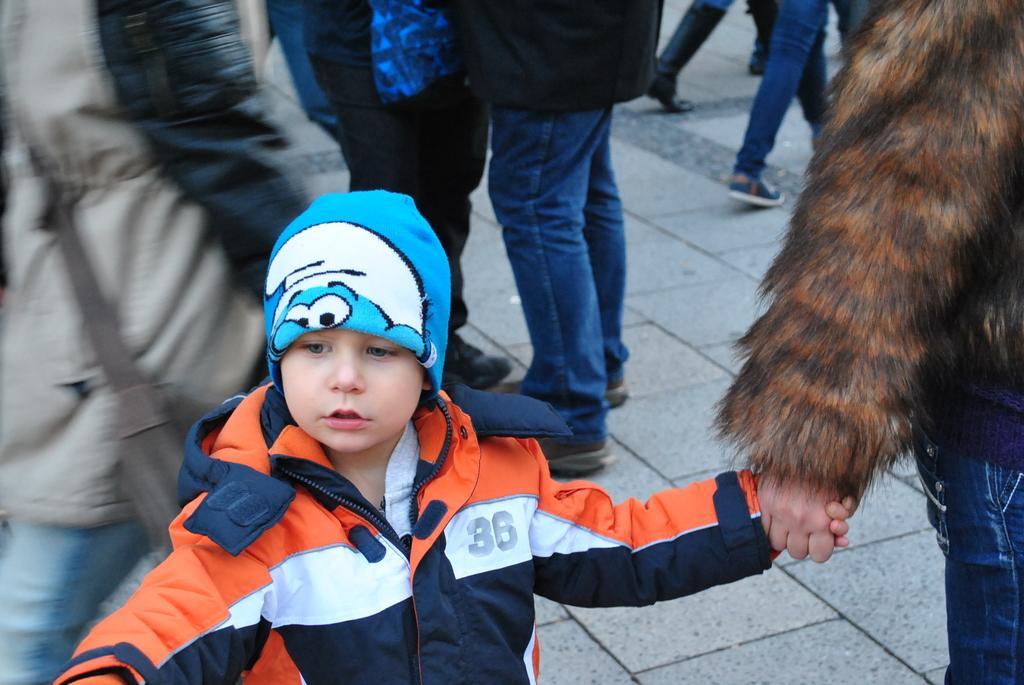Describe this image in one or two sentences. In this image I can see a child wearing white, black and orange colored jacket is standing and holding another person's hand. In the background I can see few persons standing on the ground. 